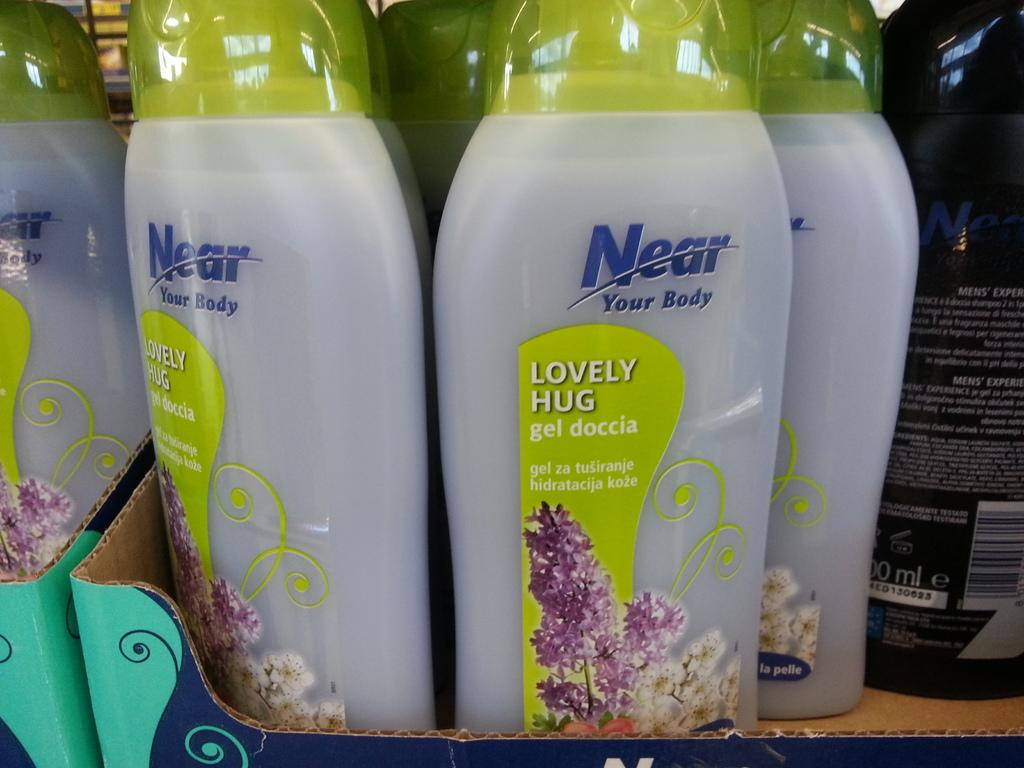<image>
Summarize the visual content of the image. bottles of Near Lovely Hug sit on a shelf at the store 